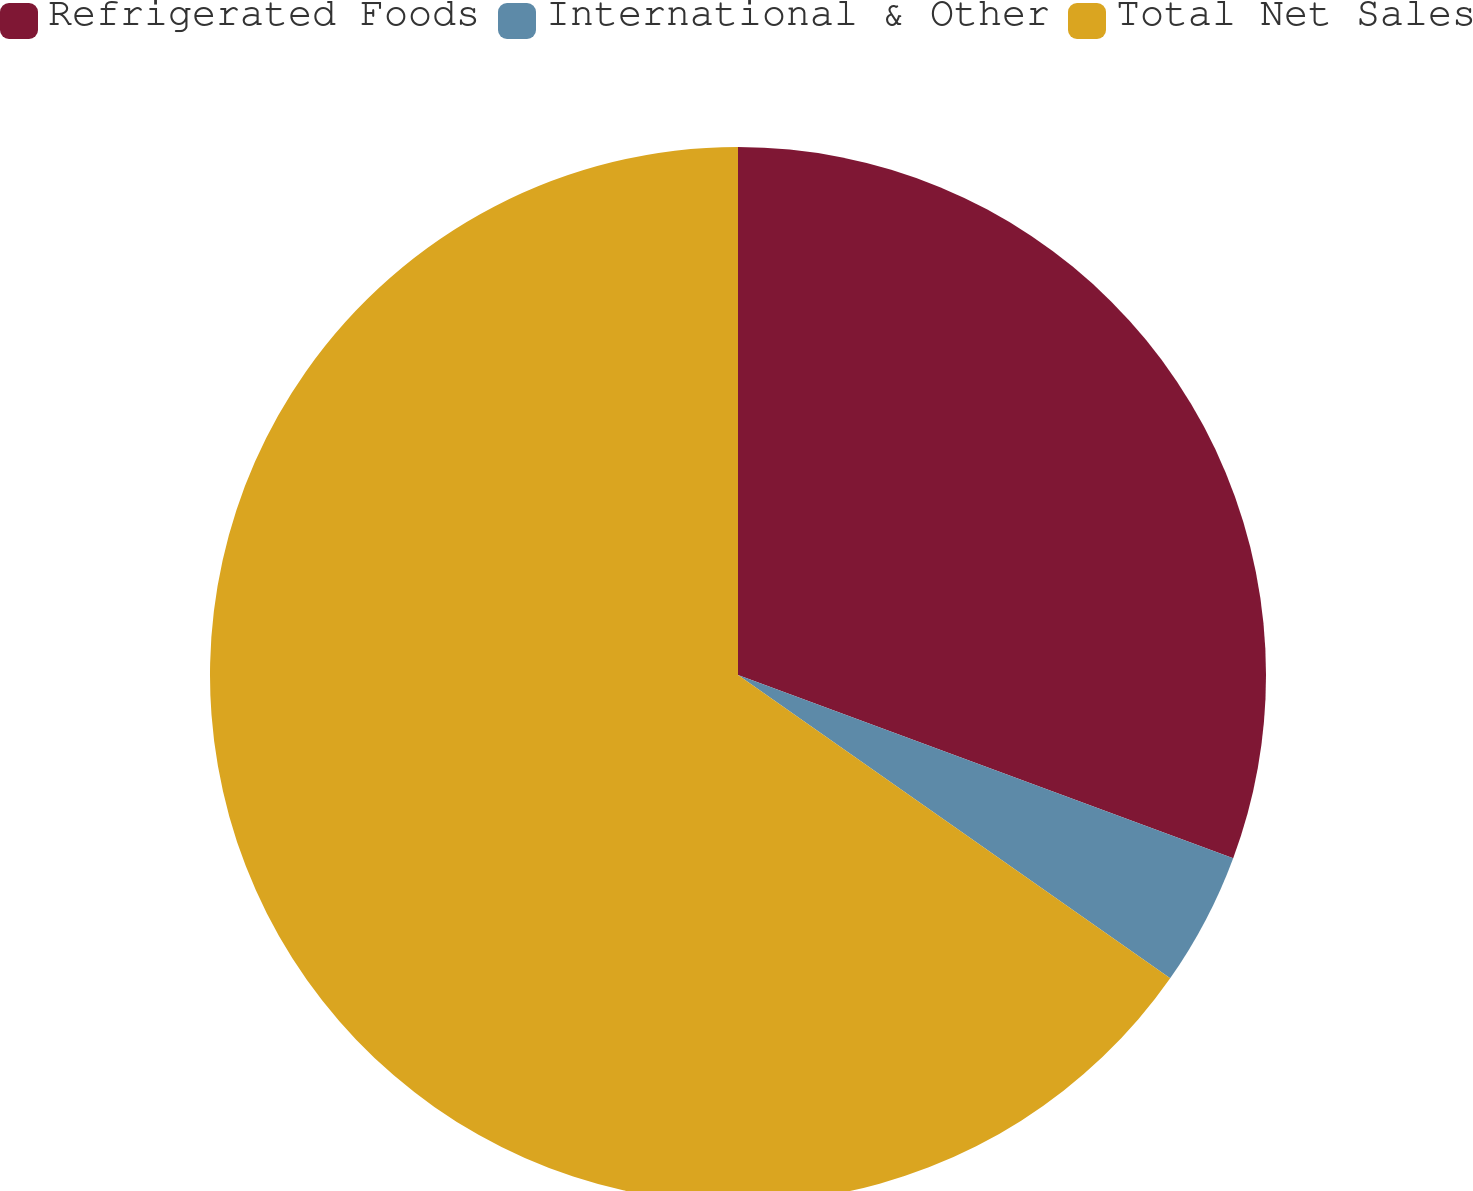Convert chart. <chart><loc_0><loc_0><loc_500><loc_500><pie_chart><fcel>Refrigerated Foods<fcel>International & Other<fcel>Total Net Sales<nl><fcel>30.64%<fcel>4.1%<fcel>65.26%<nl></chart> 